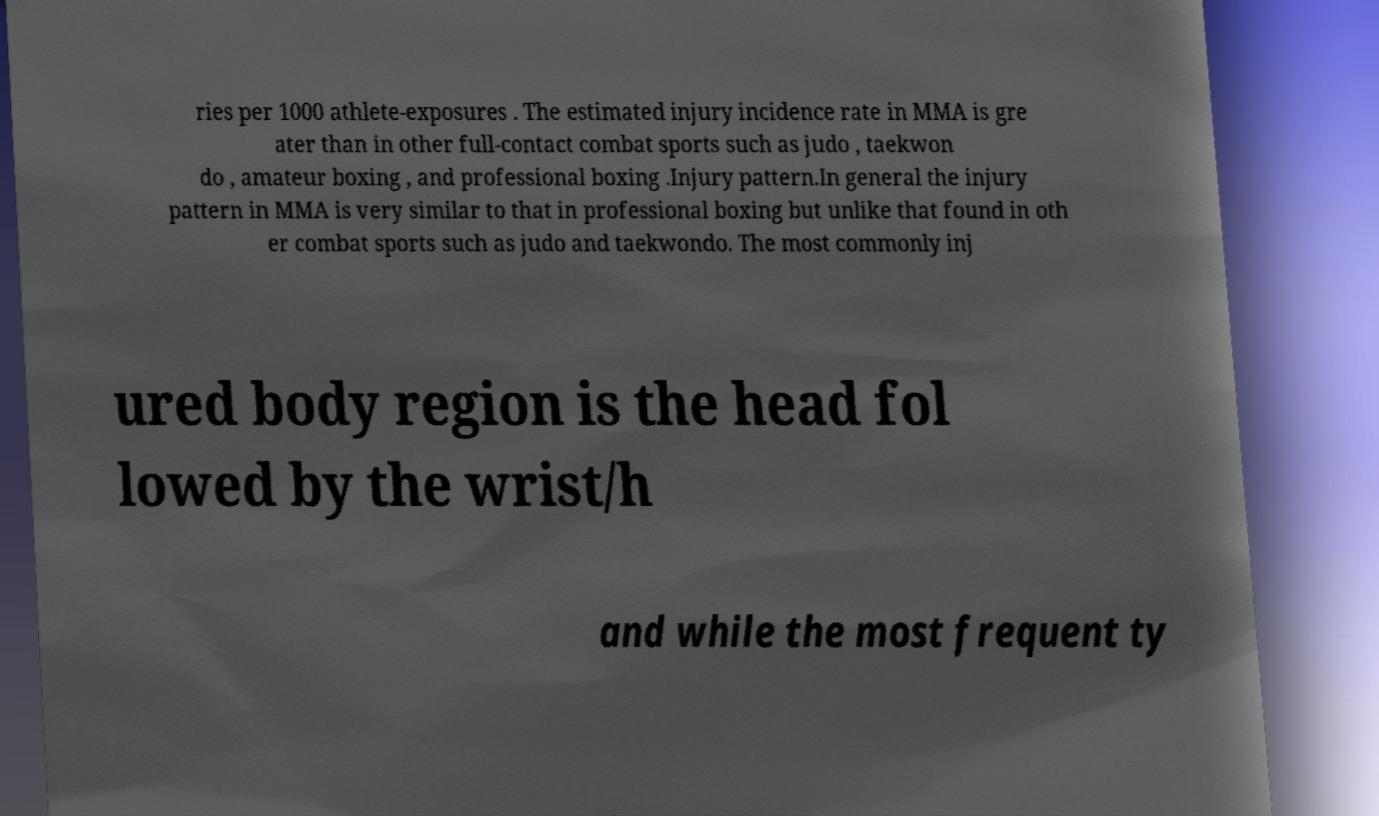There's text embedded in this image that I need extracted. Can you transcribe it verbatim? ries per 1000 athlete-exposures . The estimated injury incidence rate in MMA is gre ater than in other full-contact combat sports such as judo , taekwon do , amateur boxing , and professional boxing .Injury pattern.In general the injury pattern in MMA is very similar to that in professional boxing but unlike that found in oth er combat sports such as judo and taekwondo. The most commonly inj ured body region is the head fol lowed by the wrist/h and while the most frequent ty 